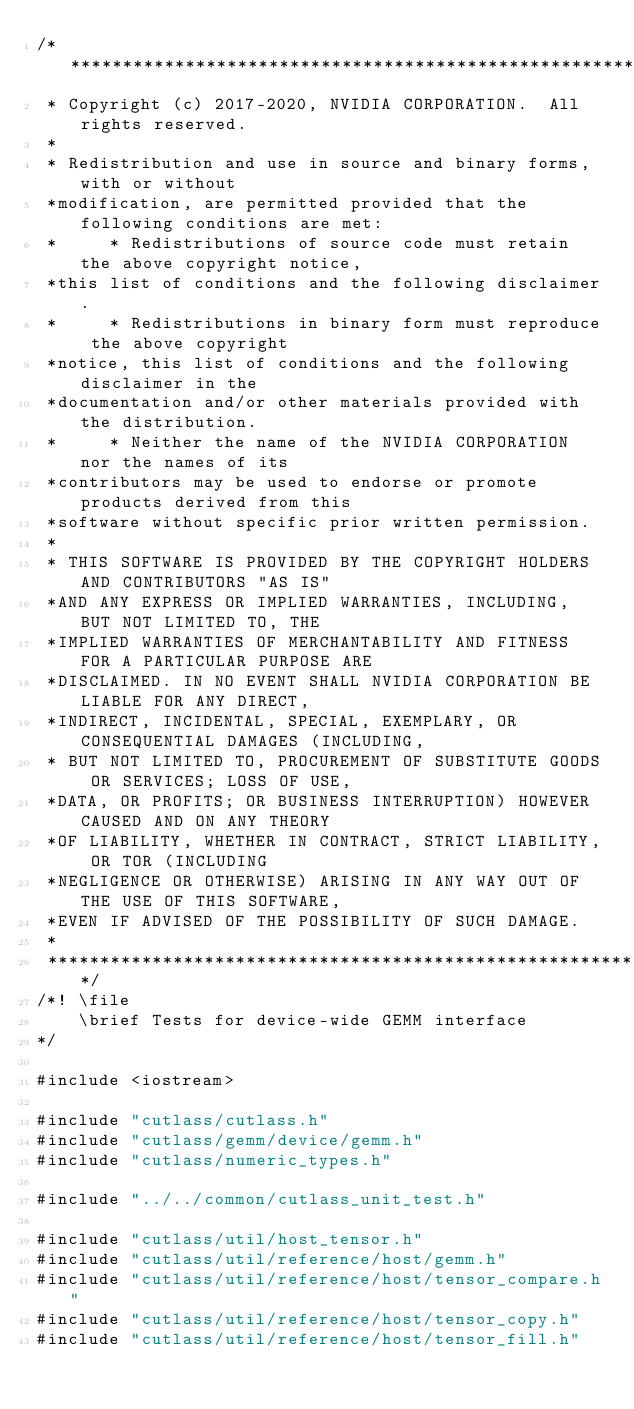Convert code to text. <code><loc_0><loc_0><loc_500><loc_500><_Cuda_>/***************************************************************************************************
 * Copyright (c) 2017-2020, NVIDIA CORPORATION.  All rights reserved.
 *
 * Redistribution and use in source and binary forms, with or without
 *modification, are permitted provided that the following conditions are met:
 *     * Redistributions of source code must retain the above copyright notice,
 *this list of conditions and the following disclaimer.
 *     * Redistributions in binary form must reproduce the above copyright
 *notice, this list of conditions and the following disclaimer in the
 *documentation and/or other materials provided with the distribution.
 *     * Neither the name of the NVIDIA CORPORATION nor the names of its
 *contributors may be used to endorse or promote products derived from this
 *software without specific prior written permission.
 *
 * THIS SOFTWARE IS PROVIDED BY THE COPYRIGHT HOLDERS AND CONTRIBUTORS "AS IS"
 *AND ANY EXPRESS OR IMPLIED WARRANTIES, INCLUDING, BUT NOT LIMITED TO, THE
 *IMPLIED WARRANTIES OF MERCHANTABILITY AND FITNESS FOR A PARTICULAR PURPOSE ARE
 *DISCLAIMED. IN NO EVENT SHALL NVIDIA CORPORATION BE LIABLE FOR ANY DIRECT,
 *INDIRECT, INCIDENTAL, SPECIAL, EXEMPLARY, OR CONSEQUENTIAL DAMAGES (INCLUDING,
 * BUT NOT LIMITED TO, PROCUREMENT OF SUBSTITUTE GOODS OR SERVICES; LOSS OF USE,
 *DATA, OR PROFITS; OR BUSINESS INTERRUPTION) HOWEVER CAUSED AND ON ANY THEORY
 *OF LIABILITY, WHETHER IN CONTRACT, STRICT LIABILITY, OR TOR (INCLUDING
 *NEGLIGENCE OR OTHERWISE) ARISING IN ANY WAY OUT OF THE USE OF THIS SOFTWARE,
 *EVEN IF ADVISED OF THE POSSIBILITY OF SUCH DAMAGE.
 *
 **************************************************************************************************/
/*! \file
    \brief Tests for device-wide GEMM interface
*/

#include <iostream>

#include "cutlass/cutlass.h"
#include "cutlass/gemm/device/gemm.h"
#include "cutlass/numeric_types.h"

#include "../../common/cutlass_unit_test.h"

#include "cutlass/util/host_tensor.h"
#include "cutlass/util/reference/host/gemm.h"
#include "cutlass/util/reference/host/tensor_compare.h"
#include "cutlass/util/reference/host/tensor_copy.h"
#include "cutlass/util/reference/host/tensor_fill.h"</code> 